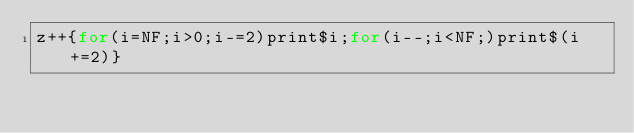Convert code to text. <code><loc_0><loc_0><loc_500><loc_500><_Awk_>z++{for(i=NF;i>0;i-=2)print$i;for(i--;i<NF;)print$(i+=2)}</code> 